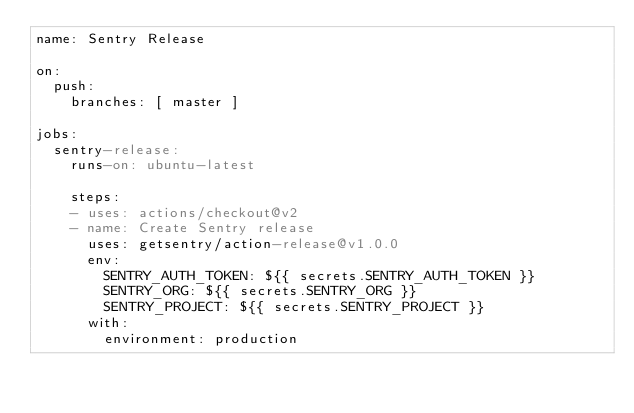Convert code to text. <code><loc_0><loc_0><loc_500><loc_500><_YAML_>name: Sentry Release

on:
  push:
    branches: [ master ]

jobs:
  sentry-release:
    runs-on: ubuntu-latest

    steps:
    - uses: actions/checkout@v2
    - name: Create Sentry release
      uses: getsentry/action-release@v1.0.0
      env:
        SENTRY_AUTH_TOKEN: ${{ secrets.SENTRY_AUTH_TOKEN }}
        SENTRY_ORG: ${{ secrets.SENTRY_ORG }}
        SENTRY_PROJECT: ${{ secrets.SENTRY_PROJECT }}
      with:
        environment: production
</code> 